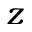<formula> <loc_0><loc_0><loc_500><loc_500>z</formula> 